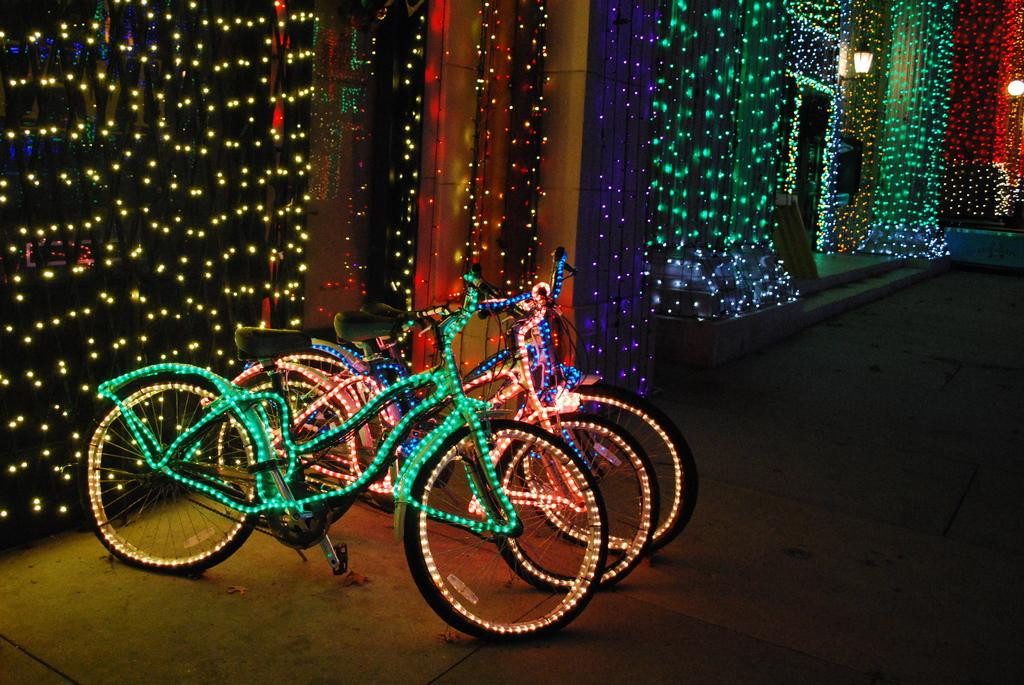What type of vehicles are in the image? There are cycles in the image. What feature can be seen on the cycles? There is lighting on the cycles. What is visible in the background of the image? There is a wall in the background of the image. What feature can be seen on the wall? There is lighting on the wall. How does the beginner rider handle the debt on their cycle in the image? There is no mention of a beginner rider or debt in the image; it only features cycles with lighting and a wall with lighting in the background. 